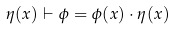<formula> <loc_0><loc_0><loc_500><loc_500>\eta ( x ) \vdash \phi = \phi ( x ) \cdot \eta ( x )</formula> 